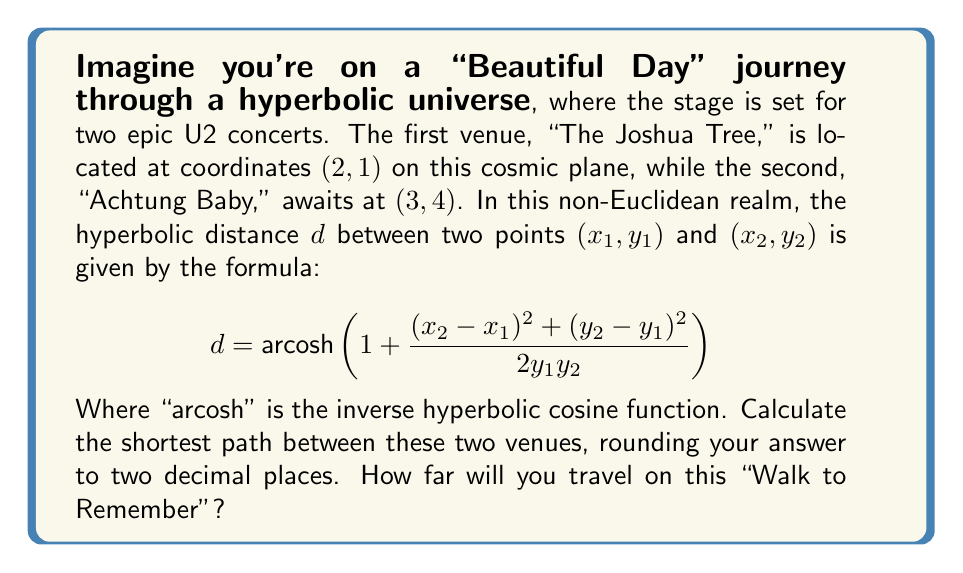Can you solve this math problem? Let's break this down step-by-step, like peeling back the layers of a U2 song:

1) We have two points:
   $(x_1, y_1) = (2, 1)$ for "The Joshua Tree"
   $(x_2, y_2) = (3, 4)$ for "Achtung Baby"

2) Let's plug these into our hyperbolic distance formula:

   $$ d = \text{arcosh}\left(1 + \frac{(3 - 2)^2 + (4 - 1)^2}{2(1)(4)}\right) $$

3) Simplify the numerator:
   $$ d = \text{arcosh}\left(1 + \frac{1^2 + 3^2}{8}\right) $$

4) Calculate:
   $$ d = \text{arcosh}\left(1 + \frac{1 + 9}{8}\right) = \text{arcosh}\left(1 + \frac{10}{8}\right) = \text{arcosh}\left(\frac{18}{8}\right) = \text{arcosh}(2.25) $$

5) Use a calculator or computer to evaluate arcosh(2.25):
   $$ d \approx 1.4722 $$

6) Rounding to two decimal places:
   $$ d \approx 1.47 $$

This journey through hyperbolic space, much like U2's musical evolution, takes us on a path that's not quite what we're used to in our Euclidean world. The shortest route between these cosmic venues bends and curves in ways that might surprise a traveler accustomed to flat planes and straight lines.
Answer: 1.47 